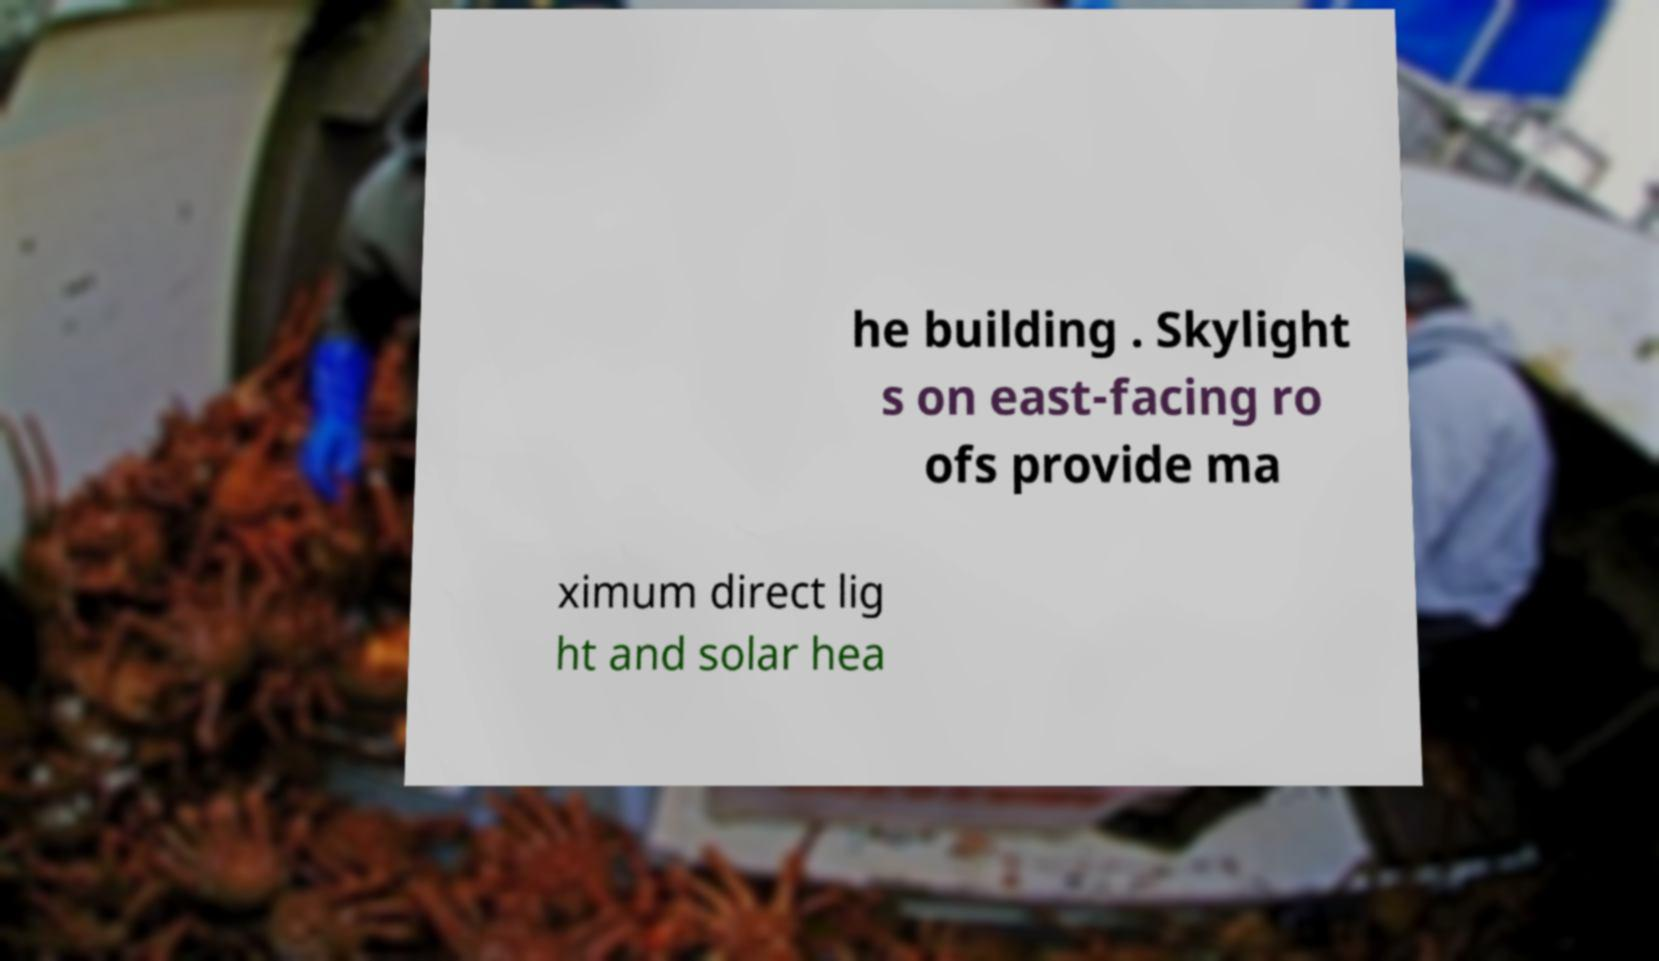For documentation purposes, I need the text within this image transcribed. Could you provide that? he building . Skylight s on east-facing ro ofs provide ma ximum direct lig ht and solar hea 